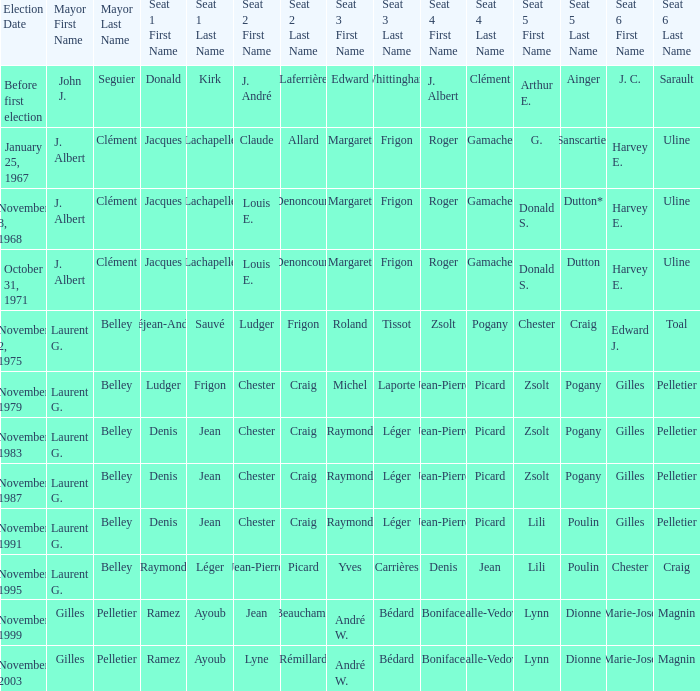When jacques lachapelle was in seat no 1 and donald s. dutton was in seat no 5, who occupied seat no 6? Harvey E. Uline. 